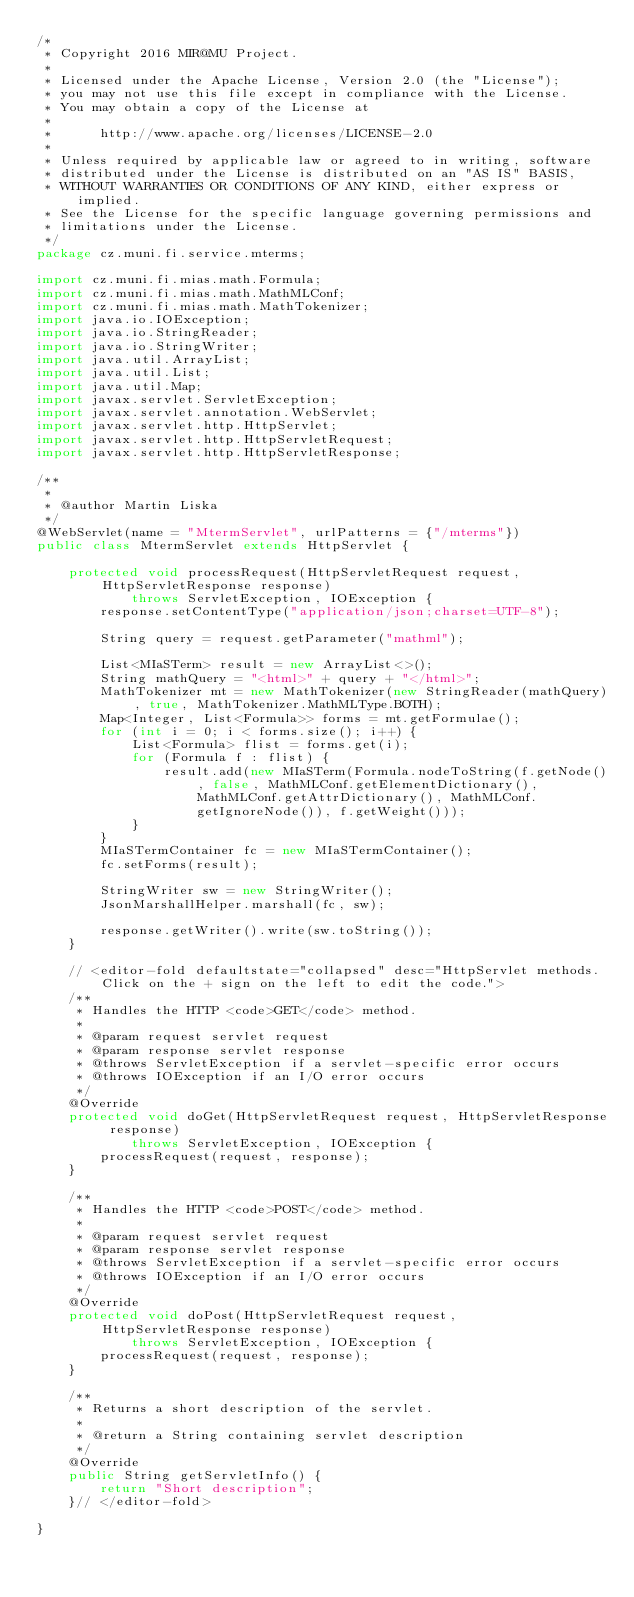Convert code to text. <code><loc_0><loc_0><loc_500><loc_500><_Java_>/*
 * Copyright 2016 MIR@MU Project.
 *
 * Licensed under the Apache License, Version 2.0 (the "License");
 * you may not use this file except in compliance with the License.
 * You may obtain a copy of the License at
 *
 *      http://www.apache.org/licenses/LICENSE-2.0
 *
 * Unless required by applicable law or agreed to in writing, software
 * distributed under the License is distributed on an "AS IS" BASIS,
 * WITHOUT WARRANTIES OR CONDITIONS OF ANY KIND, either express or implied.
 * See the License for the specific language governing permissions and
 * limitations under the License.
 */
package cz.muni.fi.service.mterms;

import cz.muni.fi.mias.math.Formula;
import cz.muni.fi.mias.math.MathMLConf;
import cz.muni.fi.mias.math.MathTokenizer;
import java.io.IOException;
import java.io.StringReader;
import java.io.StringWriter;
import java.util.ArrayList;
import java.util.List;
import java.util.Map;
import javax.servlet.ServletException;
import javax.servlet.annotation.WebServlet;
import javax.servlet.http.HttpServlet;
import javax.servlet.http.HttpServletRequest;
import javax.servlet.http.HttpServletResponse;

/**
 *
 * @author Martin Liska
 */
@WebServlet(name = "MtermServlet", urlPatterns = {"/mterms"})
public class MtermServlet extends HttpServlet {

    protected void processRequest(HttpServletRequest request, HttpServletResponse response)
            throws ServletException, IOException {
        response.setContentType("application/json;charset=UTF-8");

        String query = request.getParameter("mathml");

        List<MIaSTerm> result = new ArrayList<>();
        String mathQuery = "<html>" + query + "</html>";
        MathTokenizer mt = new MathTokenizer(new StringReader(mathQuery), true, MathTokenizer.MathMLType.BOTH);
        Map<Integer, List<Formula>> forms = mt.getFormulae();
        for (int i = 0; i < forms.size(); i++) {
            List<Formula> flist = forms.get(i);
            for (Formula f : flist) {
                result.add(new MIaSTerm(Formula.nodeToString(f.getNode(), false, MathMLConf.getElementDictionary(), MathMLConf.getAttrDictionary(), MathMLConf.getIgnoreNode()), f.getWeight()));
            }
        }
        MIaSTermContainer fc = new MIaSTermContainer();
        fc.setForms(result);

        StringWriter sw = new StringWriter();
        JsonMarshallHelper.marshall(fc, sw);

        response.getWriter().write(sw.toString());
    }

    // <editor-fold defaultstate="collapsed" desc="HttpServlet methods. Click on the + sign on the left to edit the code.">
    /**
     * Handles the HTTP <code>GET</code> method.
     *
     * @param request servlet request
     * @param response servlet response
     * @throws ServletException if a servlet-specific error occurs
     * @throws IOException if an I/O error occurs
     */
    @Override
    protected void doGet(HttpServletRequest request, HttpServletResponse response)
            throws ServletException, IOException {
        processRequest(request, response);
    }

    /**
     * Handles the HTTP <code>POST</code> method.
     *
     * @param request servlet request
     * @param response servlet response
     * @throws ServletException if a servlet-specific error occurs
     * @throws IOException if an I/O error occurs
     */
    @Override
    protected void doPost(HttpServletRequest request, HttpServletResponse response)
            throws ServletException, IOException {
        processRequest(request, response);
    }

    /**
     * Returns a short description of the servlet.
     *
     * @return a String containing servlet description
     */
    @Override
    public String getServletInfo() {
        return "Short description";
    }// </editor-fold>

}
</code> 